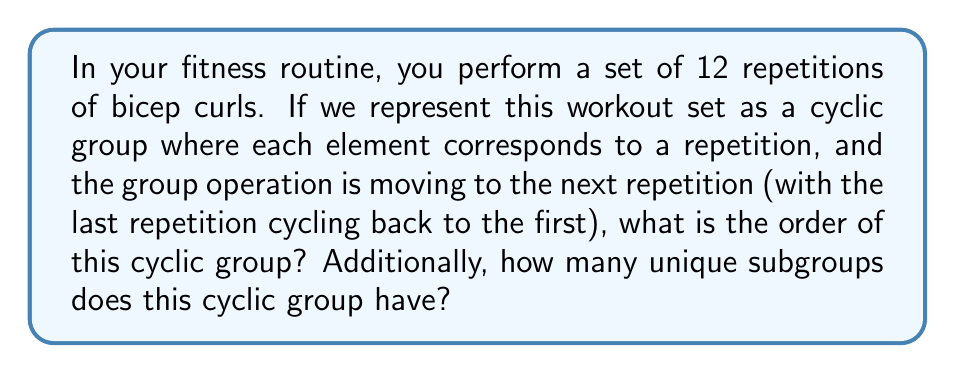Provide a solution to this math problem. Let's approach this step-by-step:

1) In group theory, a cyclic group is a group that can be generated by a single element. In this case, our generator is the operation of moving from one repetition to the next.

2) The order of a cyclic group is equal to the number of elements in the group. In our workout scenario, each repetition corresponds to an element in the group. Therefore, the order of the group is 12.

3) To find the number of unique subgroups, we need to consider a property of cyclic groups: the number of subgroups of a cyclic group of order $n$ is equal to the number of divisors of $n$.

4) The divisors of 12 are: 1, 2, 3, 4, 6, and 12.

5) Therefore, the number of unique subgroups is 6.

To visualize this, we can think of these subgroups as different ways to break down our workout:
- Subgroup of order 1: The identity element (not doing any repetitions)
- Subgroup of order 2: Doing every 6th repetition
- Subgroup of order 3: Doing every 4th repetition
- Subgroup of order 4: Doing every 3rd repetition
- Subgroup of order 6: Doing every 2nd repetition
- Subgroup of order 12: The entire set of repetitions

Each of these represents a unique way to cycle through our workout set, corresponding to a unique subgroup of our cyclic group.
Answer: The order of the cyclic group is 12, and it has 6 unique subgroups. 